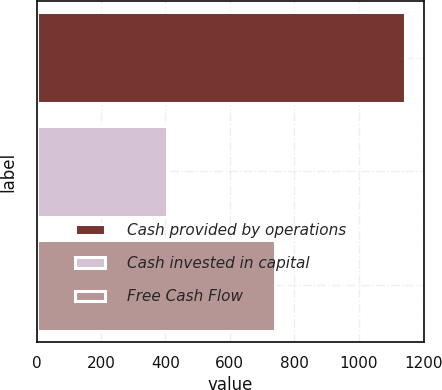Convert chart. <chart><loc_0><loc_0><loc_500><loc_500><bar_chart><fcel>Cash provided by operations<fcel>Cash invested in capital<fcel>Free Cash Flow<nl><fcel>1144<fcel>405<fcel>739<nl></chart> 